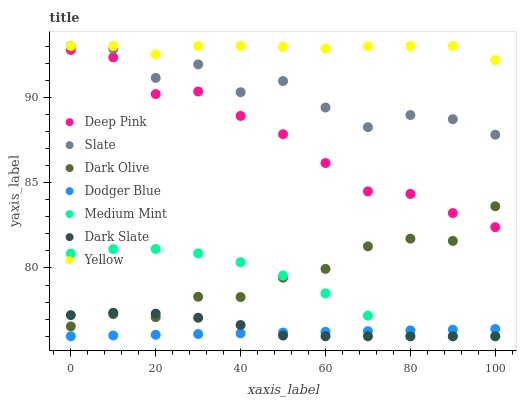Does Dodger Blue have the minimum area under the curve?
Answer yes or no. Yes. Does Yellow have the maximum area under the curve?
Answer yes or no. Yes. Does Deep Pink have the minimum area under the curve?
Answer yes or no. No. Does Deep Pink have the maximum area under the curve?
Answer yes or no. No. Is Dodger Blue the smoothest?
Answer yes or no. Yes. Is Slate the roughest?
Answer yes or no. Yes. Is Deep Pink the smoothest?
Answer yes or no. No. Is Deep Pink the roughest?
Answer yes or no. No. Does Medium Mint have the lowest value?
Answer yes or no. Yes. Does Deep Pink have the lowest value?
Answer yes or no. No. Does Yellow have the highest value?
Answer yes or no. Yes. Does Deep Pink have the highest value?
Answer yes or no. No. Is Dodger Blue less than Slate?
Answer yes or no. Yes. Is Slate greater than Deep Pink?
Answer yes or no. Yes. Does Dark Olive intersect Dark Slate?
Answer yes or no. Yes. Is Dark Olive less than Dark Slate?
Answer yes or no. No. Is Dark Olive greater than Dark Slate?
Answer yes or no. No. Does Dodger Blue intersect Slate?
Answer yes or no. No. 